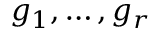Convert formula to latex. <formula><loc_0><loc_0><loc_500><loc_500>g _ { 1 } , \dots , g _ { r }</formula> 